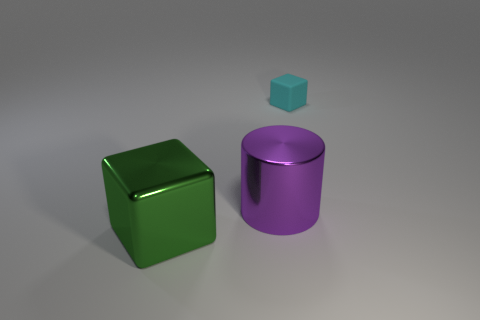Add 3 big purple things. How many objects exist? 6 Subtract 1 cylinders. How many cylinders are left? 0 Add 3 tiny cyan rubber objects. How many tiny cyan rubber objects are left? 4 Add 1 metal things. How many metal things exist? 3 Subtract 0 yellow balls. How many objects are left? 3 Subtract all cubes. How many objects are left? 1 Subtract all brown cylinders. Subtract all purple balls. How many cylinders are left? 1 Subtract all brown cylinders. How many cyan cubes are left? 1 Subtract all big things. Subtract all large purple metallic things. How many objects are left? 0 